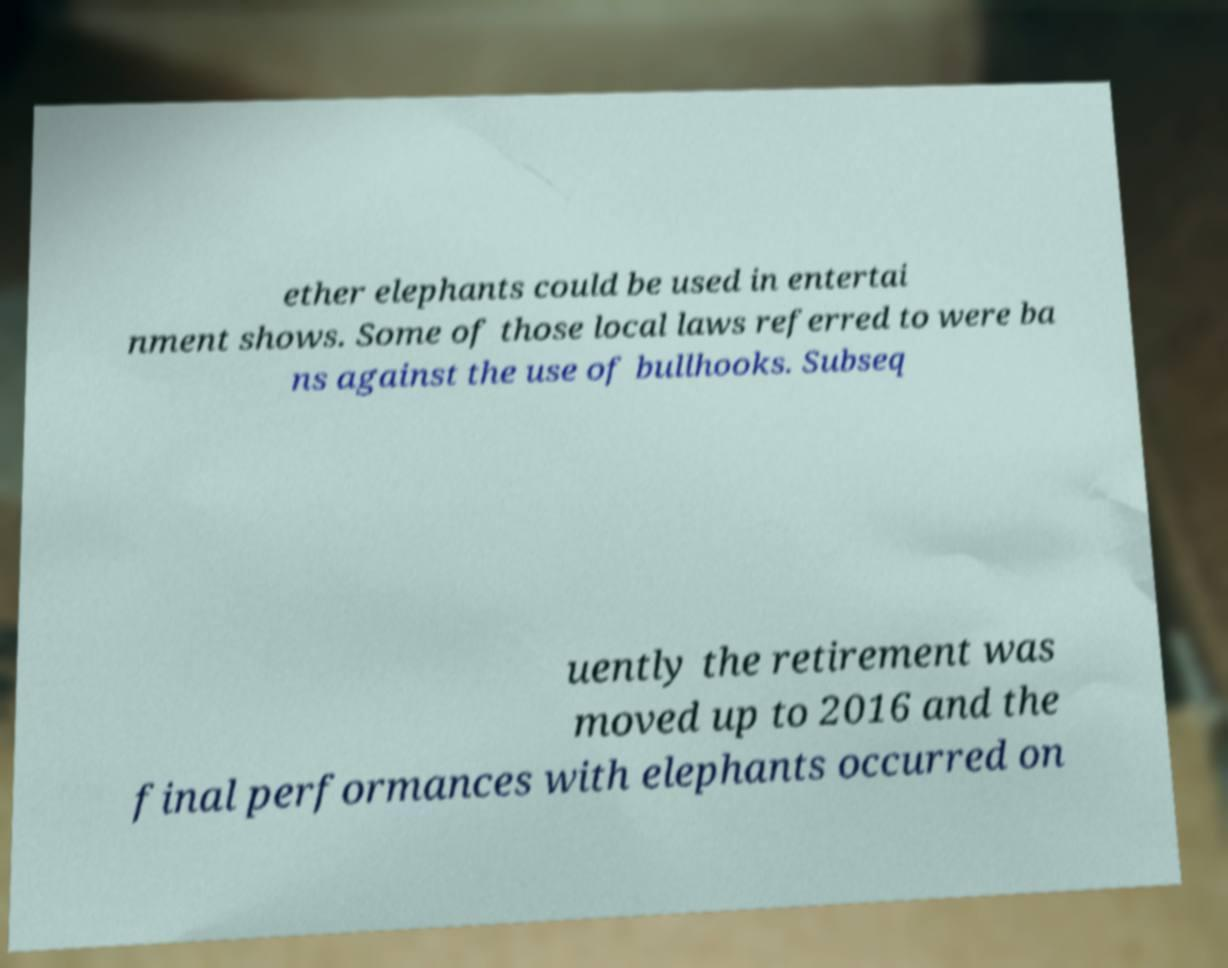There's text embedded in this image that I need extracted. Can you transcribe it verbatim? ether elephants could be used in entertai nment shows. Some of those local laws referred to were ba ns against the use of bullhooks. Subseq uently the retirement was moved up to 2016 and the final performances with elephants occurred on 